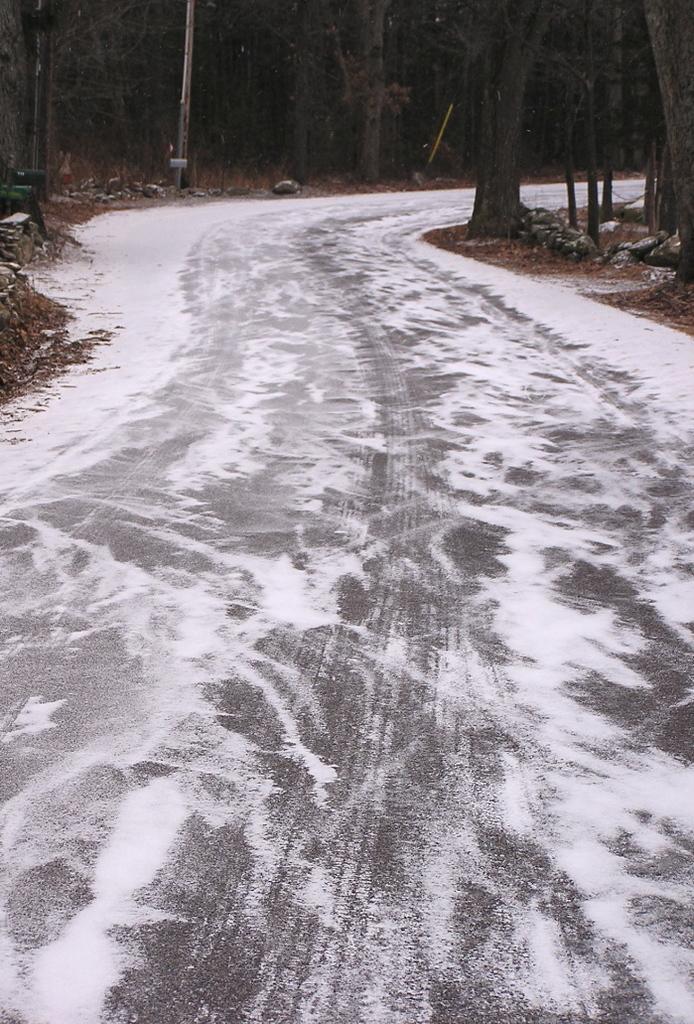In one or two sentences, can you explain what this image depicts? In this image we can see the road with frost. We can also see a group of trees and a pole. 